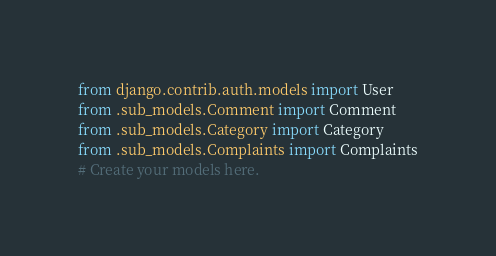Convert code to text. <code><loc_0><loc_0><loc_500><loc_500><_Python_>from django.contrib.auth.models import User
from .sub_models.Comment import Comment
from .sub_models.Category import Category
from .sub_models.Complaints import Complaints
# Create your models here.


</code> 